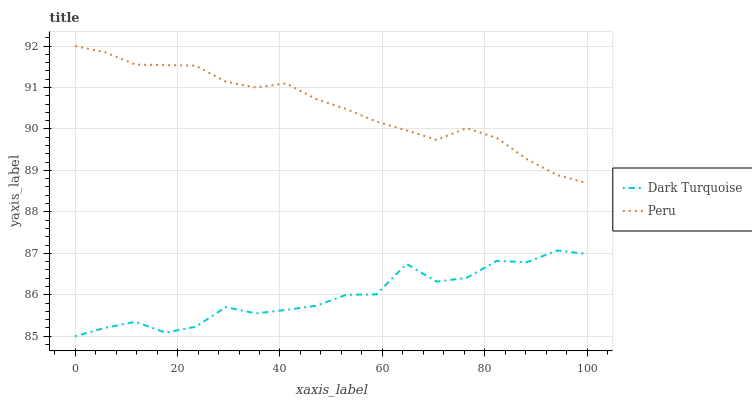Does Dark Turquoise have the minimum area under the curve?
Answer yes or no. Yes. Does Peru have the maximum area under the curve?
Answer yes or no. Yes. Does Peru have the minimum area under the curve?
Answer yes or no. No. Is Peru the smoothest?
Answer yes or no. Yes. Is Dark Turquoise the roughest?
Answer yes or no. Yes. Is Peru the roughest?
Answer yes or no. No. Does Peru have the lowest value?
Answer yes or no. No. Does Peru have the highest value?
Answer yes or no. Yes. Is Dark Turquoise less than Peru?
Answer yes or no. Yes. Is Peru greater than Dark Turquoise?
Answer yes or no. Yes. Does Dark Turquoise intersect Peru?
Answer yes or no. No. 